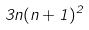Convert formula to latex. <formula><loc_0><loc_0><loc_500><loc_500>3 n ( n + 1 ) ^ { 2 }</formula> 